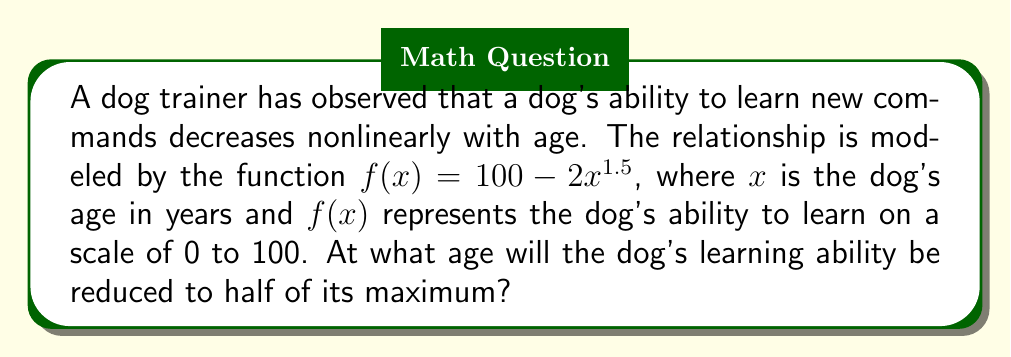Show me your answer to this math problem. To solve this problem, we'll follow these steps:

1) The maximum learning ability is when $x = 0$ (newborn puppy):
   $f(0) = 100 - 2(0)^{1.5} = 100$

2) We want to find when $f(x) = 50$, which is half of the maximum:
   $50 = 100 - 2x^{1.5}$

3) Subtract 100 from both sides:
   $-50 = -2x^{1.5}$

4) Divide both sides by -2:
   $25 = x^{1.5}$

5) To isolate $x$, we need to raise both sides to the power of $\frac{2}{3}$:
   $x = 25^{\frac{2}{3}}$

6) Calculate the result:
   $x \approx 8.98$ years

Therefore, the dog's learning ability will be reduced to half of its maximum at approximately 8.98 years of age.
Answer: $25^{\frac{2}{3}} \approx 8.98$ years 